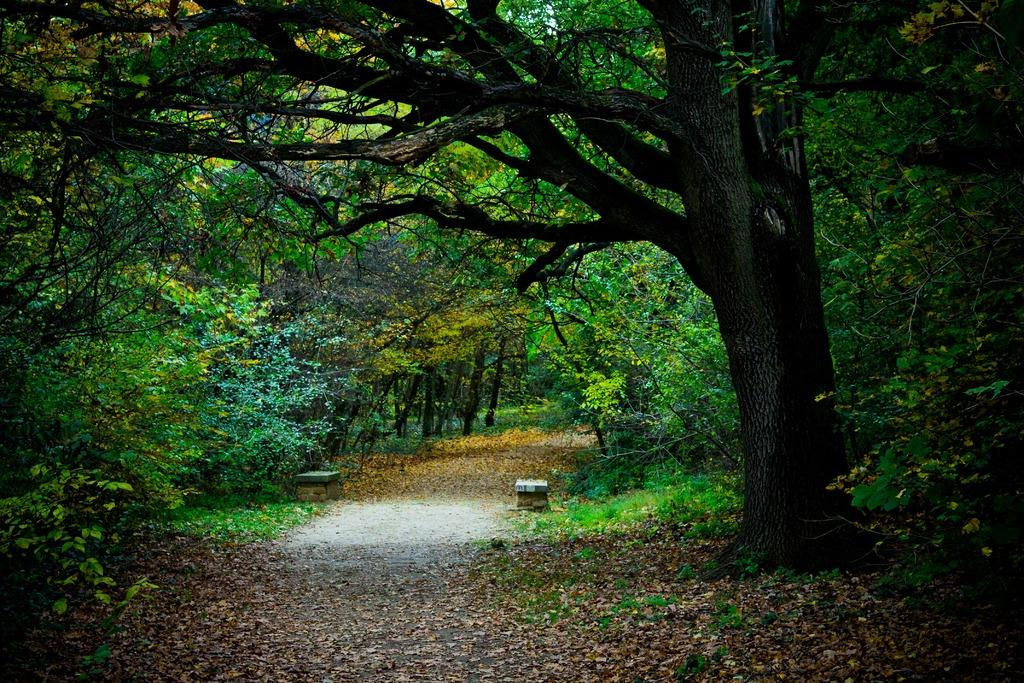What type of vegetation is in the center of the image? There are trees in the center of the image. What can people use to sit in the image? There are benches in the image. What other types of plants are visible in the image? There are plants in the image. What type of ground cover is present in the image? There is grass in the image. What additional detail can be observed on the ground? Dry leaves are visible in the image. What type of frame is visible in the image? There is no frame present in the image. Can you describe the tongue of the person in the image? There is no person, and therefore no tongue, present in the image. 